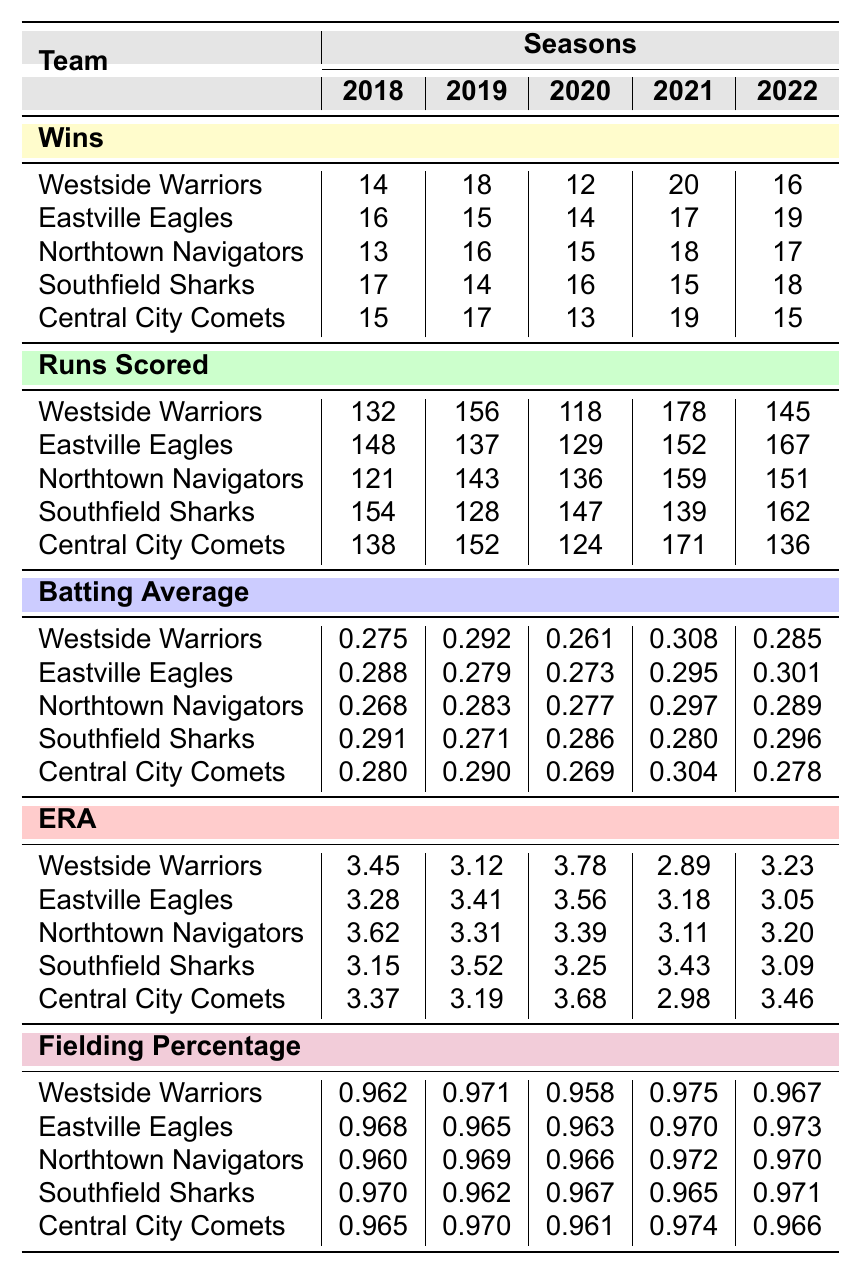What was the highest number of wins recorded by any team in 2021? Referring to the "Wins" section for the year 2021, the highest number is when the Westside Warriors won 20 games.
Answer: 20 Which team had the lowest batting average in 2020? In the "Batting Average" column for 2020, the lowest value is 0.261, which corresponds to the Westside Warriors.
Answer: Westside Warriors What is the total number of runs scored by the Eastville Eagles over the 5 seasons? Summing up the runs scored by the Eastville Eagles: 148 + 137 + 129 + 152 + 167 = 733.
Answer: 733 Did the Central City Comets have a better fielding percentage in 2019 or 2020? Comparing the fielding percentages, in 2019 it was 0.970, and in 2020 it was 0.961. Since 0.970 > 0.961, they performed better in 2019.
Answer: Yes What is the average ERA for the Southfield Sharks across all seasons? The ERA values for the Southfield Sharks are: 3.15, 3.52, 3.25, 3.43, and 3.09. The average is calculated as (3.15 + 3.52 + 3.25 + 3.43 + 3.09) / 5 = 3.27.
Answer: 3.27 Which team scored the most runs in 2022 and what was the score? Looking at the "Runs Scored" for 2022, the highest score is 167 by the Eastville Eagles.
Answer: Eastville Eagles, 167 How many teams had a batting average above 0.290 in 2021? In the "Batting Average" section for 2021, the teams with averages above 0.290 are the Westside Warriors (0.308), Eastville Eagles (0.295), and Central City Comets (0.304). So there are three teams.
Answer: 3 What is the median wins for the Northtown Navigators over the 5 seasons? The wins for Northtown Navigators are 13, 16, 15, 18, 17. Ordered: 13, 15, 16, 17, 18. The median (middle value) is 16.
Answer: 16 For which seasons did the Westside Warriors achieve a fielding percentage below 0.965? Referring to the fielding percentages for the Westside Warriors: 0.962, 0.971, 0.958, 0.975, 0.967. They were below 0.965 in 2018 and 2020.
Answer: 2018, 2020 What is the difference in wins between the Southfield Sharks in 2018 and 2022? The wins for Southfield Sharks are 17 in 2018 and 18 in 2022. The difference is 18 - 17 = 1.
Answer: 1 Which team had the best average batting percentage over the 5 seasons? Calculating the averages for each team, the team with the highest average batting percentage is the Eastville Eagles with 0.282.
Answer: Eastville Eagles 